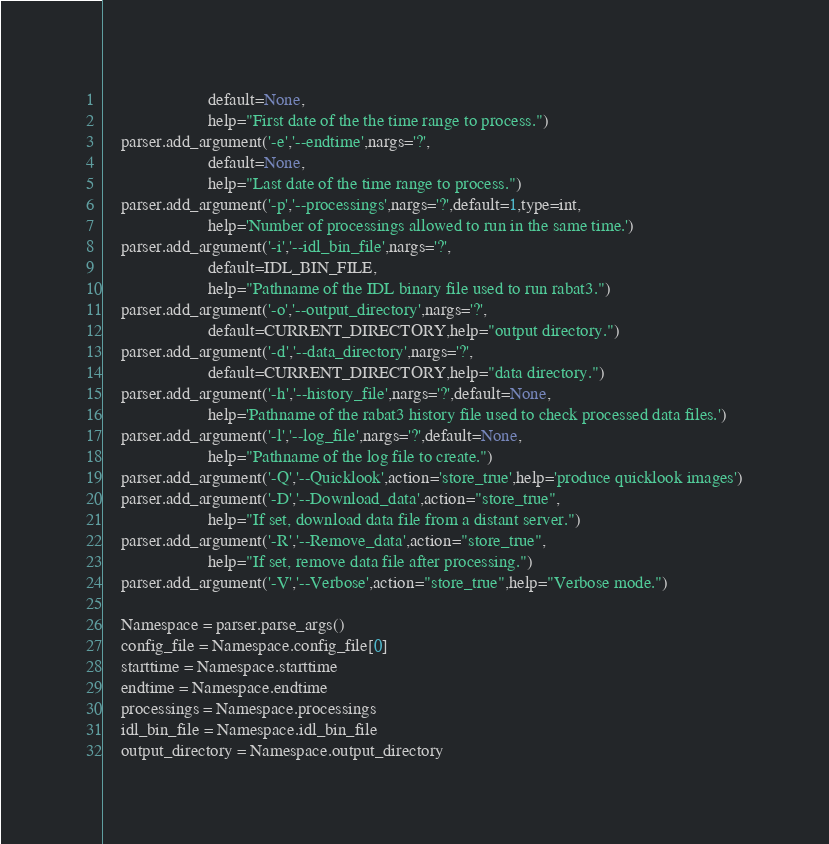Convert code to text. <code><loc_0><loc_0><loc_500><loc_500><_Python_>                        default=None,
                        help="First date of the the time range to process.")
	parser.add_argument('-e','--endtime',nargs='?',
                        default=None,
                        help="Last date of the time range to process.")
	parser.add_argument('-p','--processings',nargs='?',default=1,type=int,
                        help='Number of processings allowed to run in the same time.')
	parser.add_argument('-i','--idl_bin_file',nargs='?',
                        default=IDL_BIN_FILE,
                        help="Pathname of the IDL binary file used to run rabat3.")
	parser.add_argument('-o','--output_directory',nargs='?',
                        default=CURRENT_DIRECTORY,help="output directory.")
	parser.add_argument('-d','--data_directory',nargs='?',
                        default=CURRENT_DIRECTORY,help="data directory.")
	parser.add_argument('-h','--history_file',nargs='?',default=None,
                        help='Pathname of the rabat3 history file used to check processed data files.')
	parser.add_argument('-l','--log_file',nargs='?',default=None,
                        help="Pathname of the log file to create.")
	parser.add_argument('-Q','--Quicklook',action='store_true',help='produce quicklook images')
	parser.add_argument('-D','--Download_data',action="store_true",
                        help="If set, download data file from a distant server.")
	parser.add_argument('-R','--Remove_data',action="store_true",
                        help="If set, remove data file after processing.")
	parser.add_argument('-V','--Verbose',action="store_true",help="Verbose mode.")
	
	Namespace = parser.parse_args()
	config_file = Namespace.config_file[0]
	starttime = Namespace.starttime
	endtime = Namespace.endtime
	processings = Namespace.processings
	idl_bin_file = Namespace.idl_bin_file
	output_directory = Namespace.output_directory</code> 